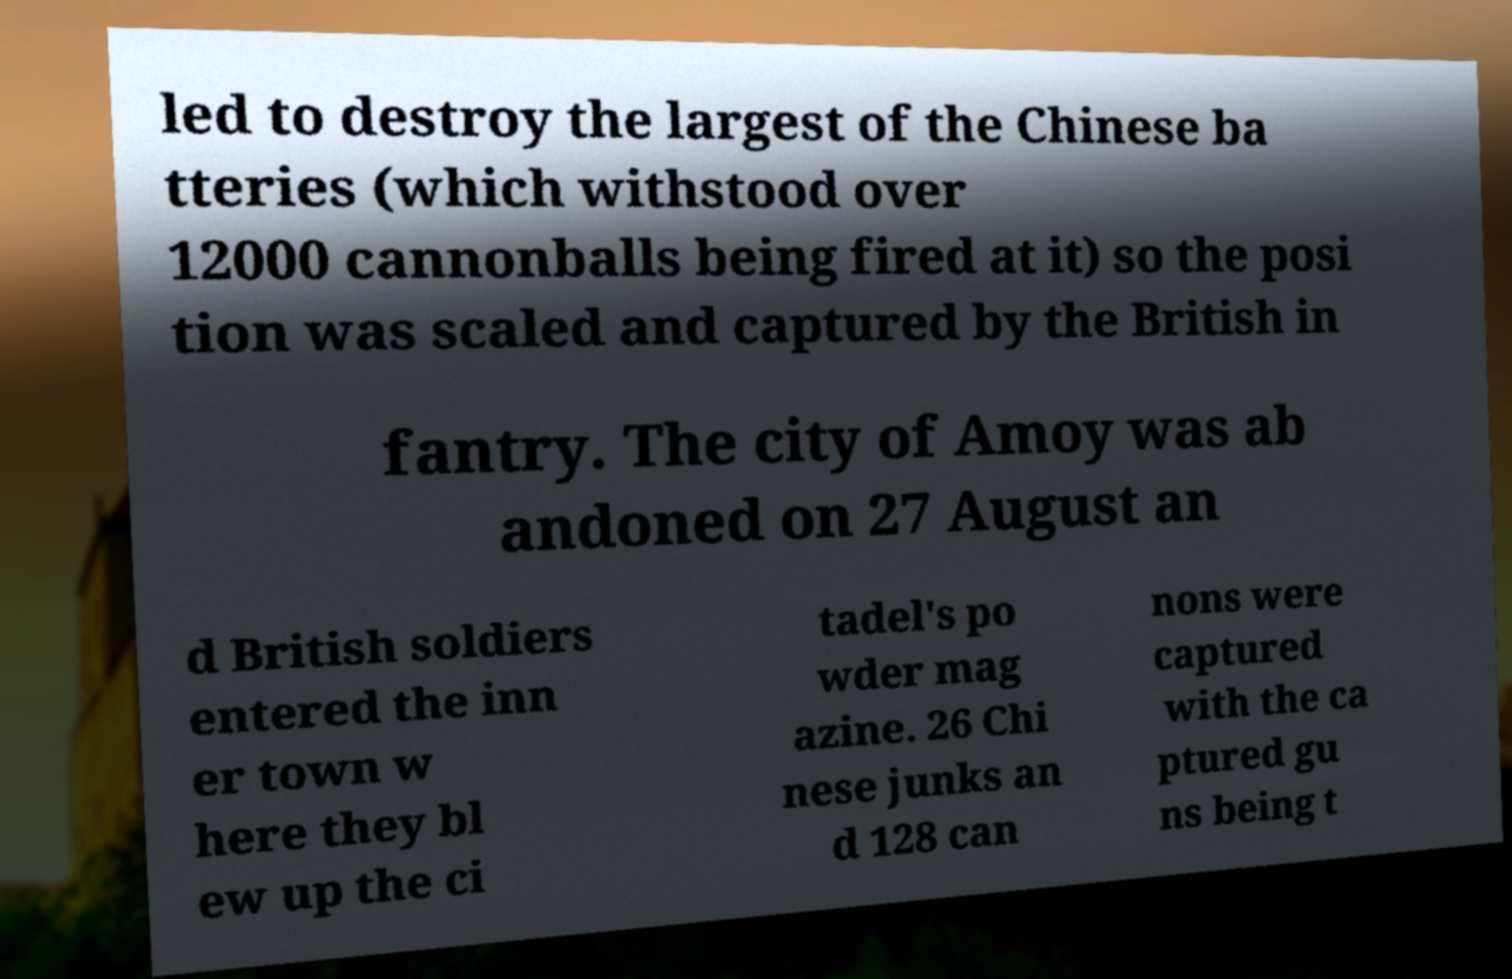I need the written content from this picture converted into text. Can you do that? led to destroy the largest of the Chinese ba tteries (which withstood over 12000 cannonballs being fired at it) so the posi tion was scaled and captured by the British in fantry. The city of Amoy was ab andoned on 27 August an d British soldiers entered the inn er town w here they bl ew up the ci tadel's po wder mag azine. 26 Chi nese junks an d 128 can nons were captured with the ca ptured gu ns being t 